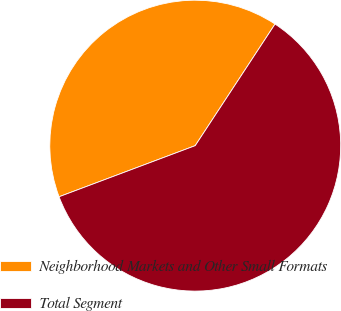Convert chart. <chart><loc_0><loc_0><loc_500><loc_500><pie_chart><fcel>Neighborhood Markets and Other Small Formats<fcel>Total Segment<nl><fcel>39.96%<fcel>60.04%<nl></chart> 